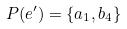Convert formula to latex. <formula><loc_0><loc_0><loc_500><loc_500>P ( e ^ { \prime } ) = \{ a _ { 1 } , b _ { 4 } \}</formula> 